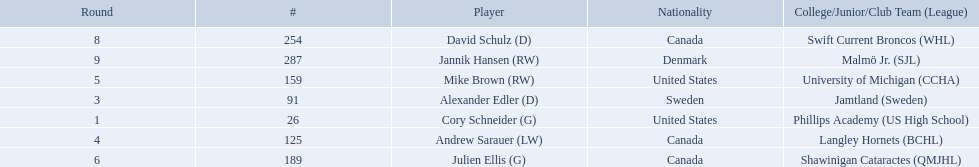Which players have canadian nationality? Andrew Sarauer (LW), Julien Ellis (G), David Schulz (D). Of those, which attended langley hornets? Andrew Sarauer (LW). 